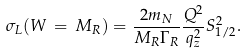Convert formula to latex. <formula><loc_0><loc_0><loc_500><loc_500>\sigma _ { L } ( W \, = \, M _ { R } ) = \frac { 2 m _ { N } } { M _ { R } \Gamma _ { R } } \frac { Q ^ { 2 } } { q ^ { 2 } _ { z } } S ^ { 2 } _ { 1 / 2 } .</formula> 